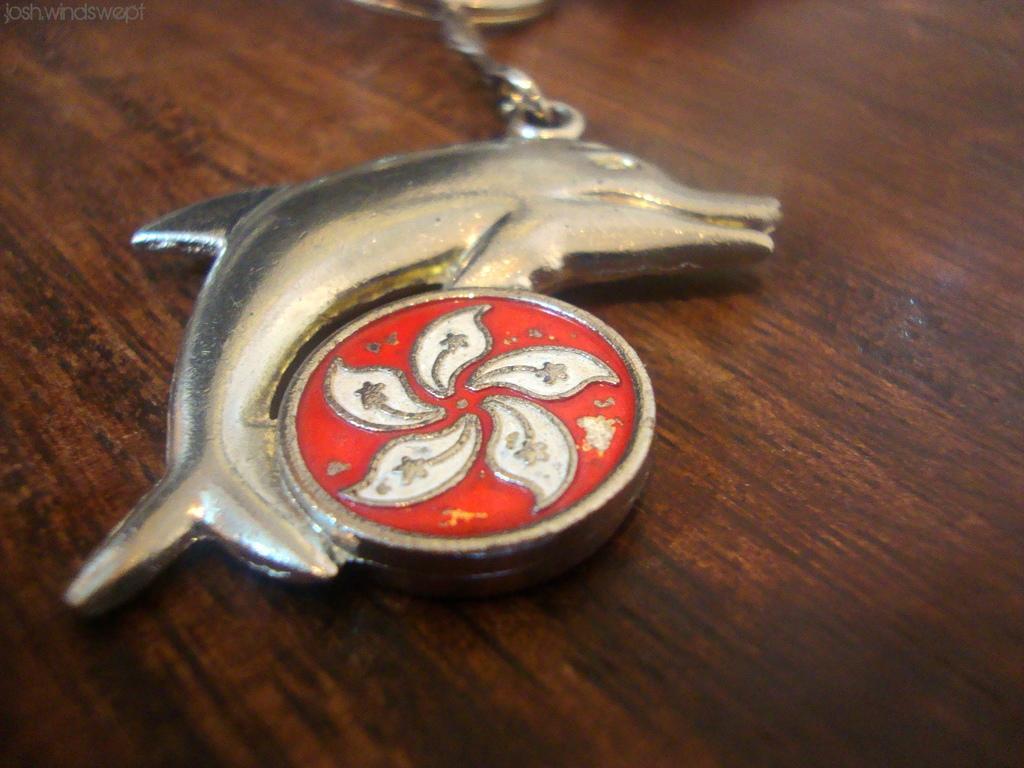Describe this image in one or two sentences. In this image we can see a silver color dolphin shaped object on the wooden surface. 